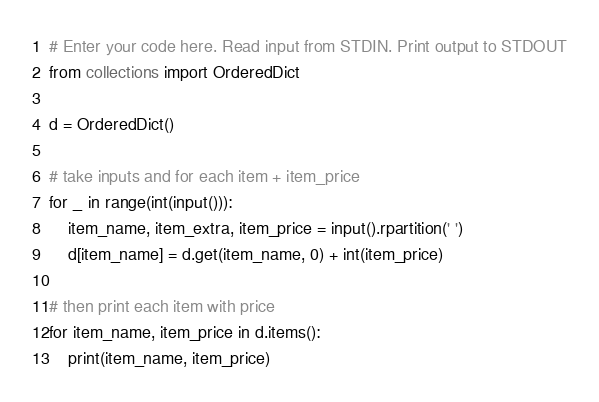<code> <loc_0><loc_0><loc_500><loc_500><_Python_># Enter your code here. Read input from STDIN. Print output to STDOUT
from collections import OrderedDict

d = OrderedDict()

# take inputs and for each item + item_price
for _ in range(int(input())):
    item_name, item_extra, item_price = input().rpartition(' ')
    d[item_name] = d.get(item_name, 0) + int(item_price)

# then print each item with price
for item_name, item_price in d.items():
    print(item_name, item_price)
</code> 